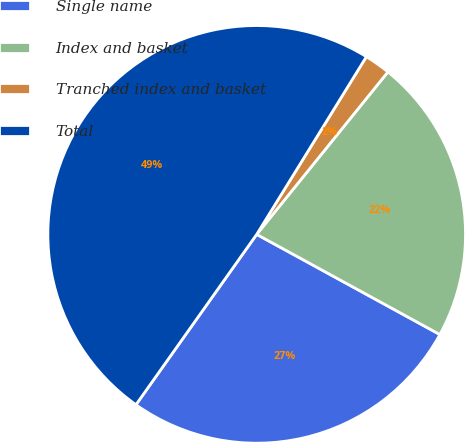Convert chart to OTSL. <chart><loc_0><loc_0><loc_500><loc_500><pie_chart><fcel>Single name<fcel>Index and basket<fcel>Tranched index and basket<fcel>Total<nl><fcel>26.85%<fcel>22.15%<fcel>2.01%<fcel>48.99%<nl></chart> 